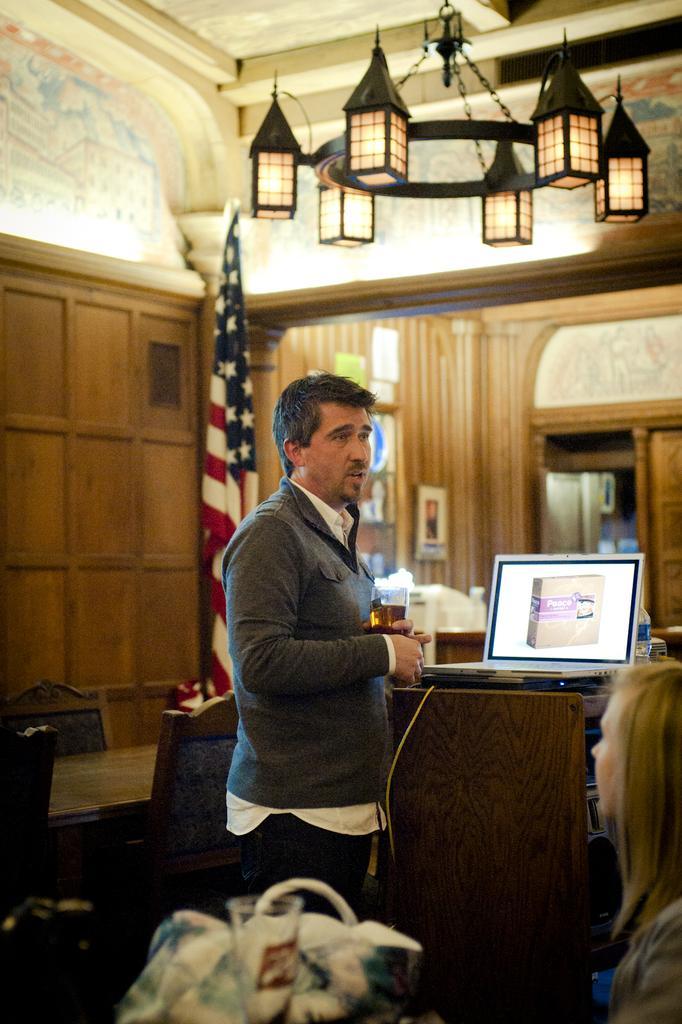Could you give a brief overview of what you see in this image? In this picture I can see a man standing and holding a wine glass, there is a person sitting, there are tables, chairs, there is a bag, glass, chandelier, there is a laptop and a bottle on one of the table, there is a flag, and in the background there are frames attached to the wall and there are some objects. 